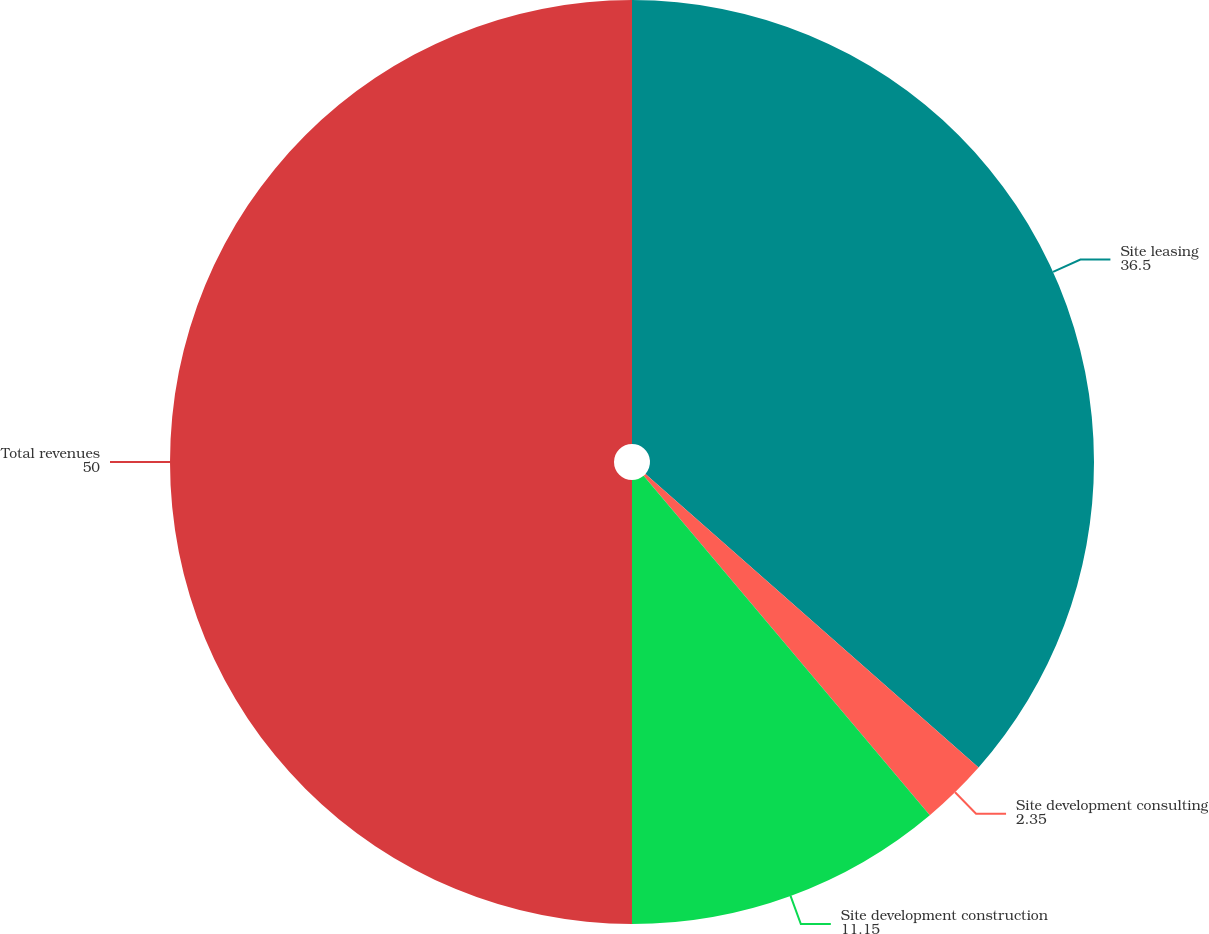Convert chart. <chart><loc_0><loc_0><loc_500><loc_500><pie_chart><fcel>Site leasing<fcel>Site development consulting<fcel>Site development construction<fcel>Total revenues<nl><fcel>36.5%<fcel>2.35%<fcel>11.15%<fcel>50.0%<nl></chart> 